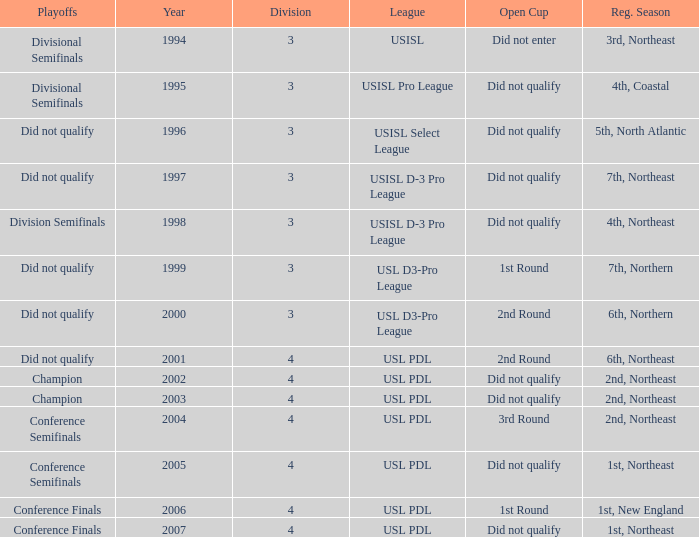Name the league for 2003 USL PDL. 